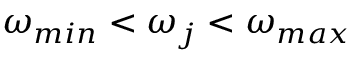<formula> <loc_0><loc_0><loc_500><loc_500>\omega _ { \min } < \omega _ { j } < \omega _ { \max }</formula> 